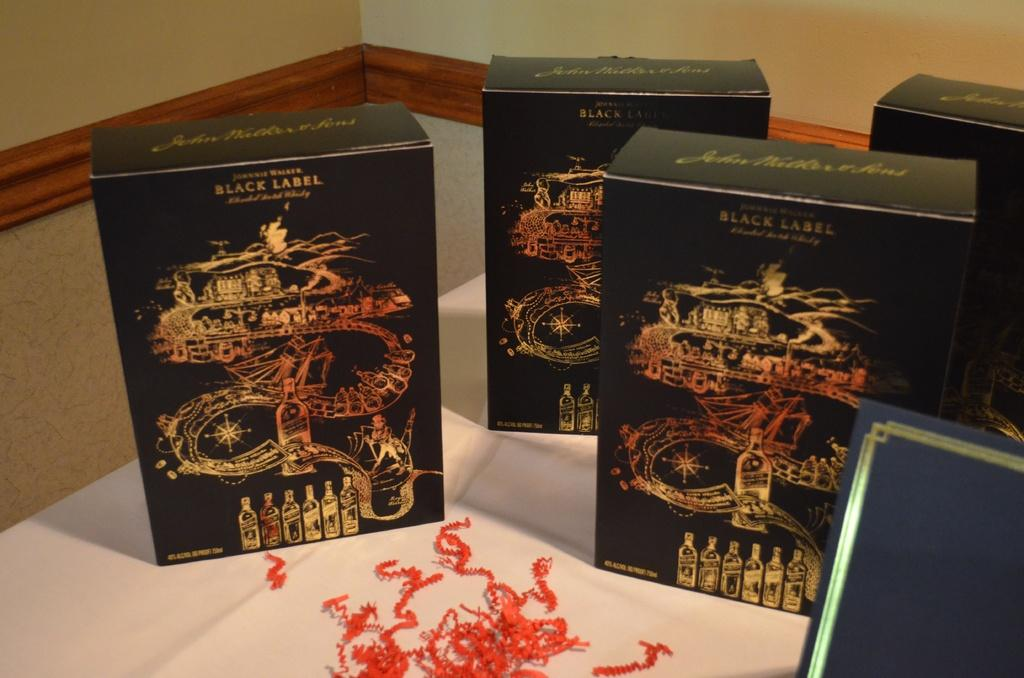<image>
Relay a brief, clear account of the picture shown. Several boxes with the brand Black Label on the top  have pictures of bottles on the bottom. 